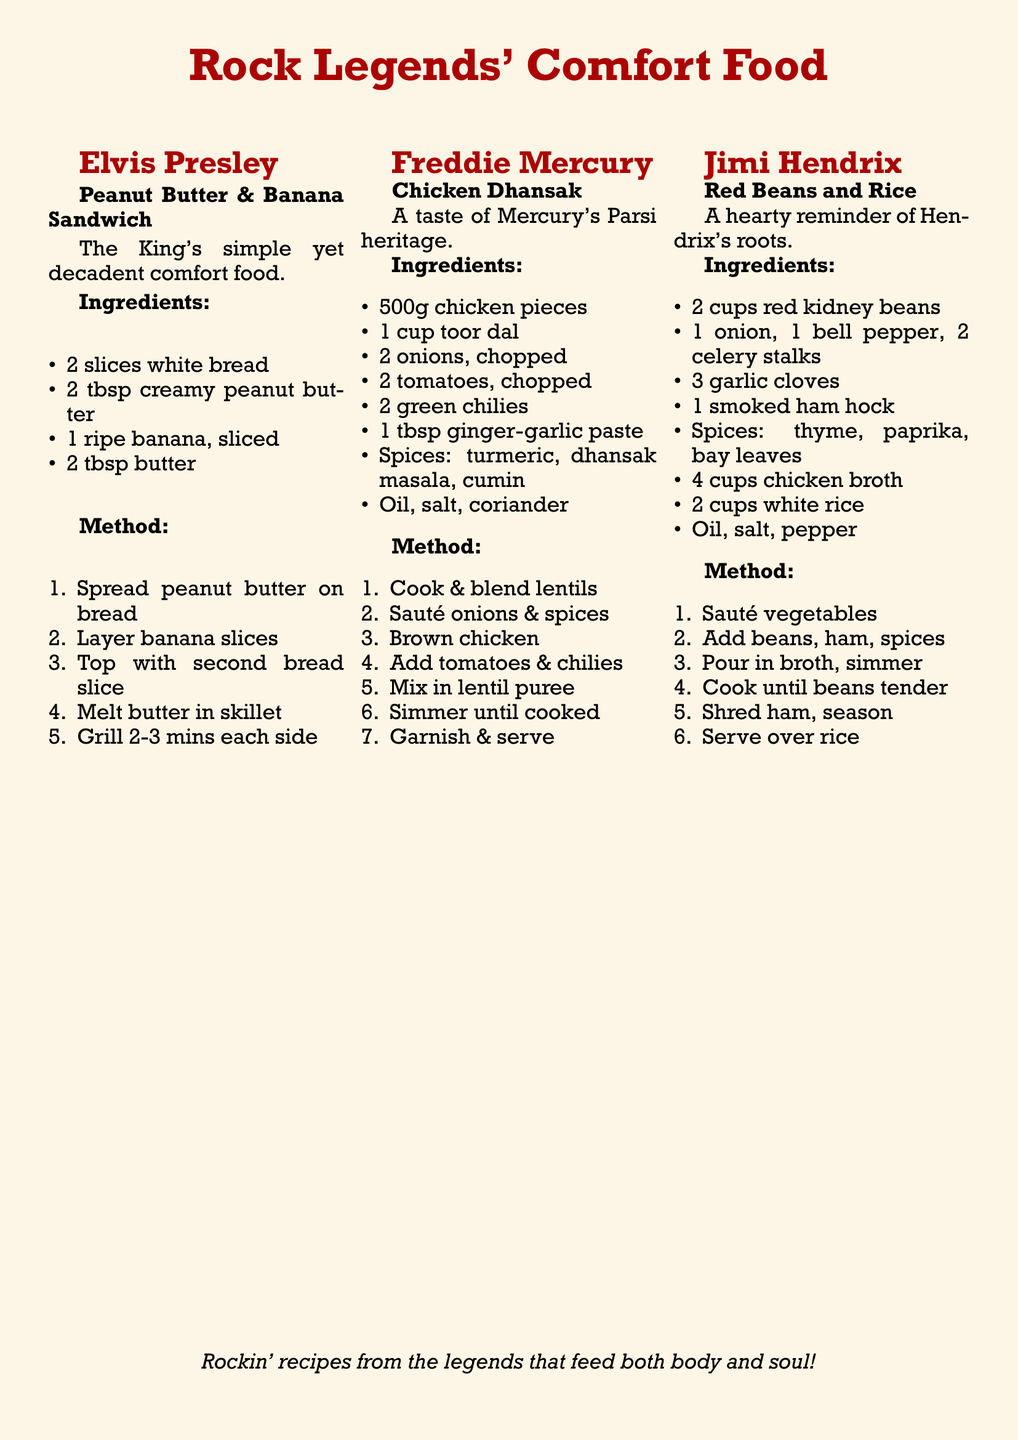What is the first recipe listed? The first recipe presented is for Elvis Presley's Peanut Butter & Banana Sandwich, which is mentioned at the beginning of the document.
Answer: Peanut Butter & Banana Sandwich Who is associated with Chicken Dhansak? The recipe for Chicken Dhansak is attributed to Freddie Mercury.
Answer: Freddie Mercury How many cups of red kidney beans are required for Jimi Hendrix's recipe? The recipe specifies 2 cups of red kidney beans as an ingredient.
Answer: 2 cups What spice is used in Chicken Dhansak? The recipe for Chicken Dhansak includes turmeric as one of the spices.
Answer: turmeric What is the cooking method for the Peanut Butter & Banana Sandwich? The method involves grilling the assembled sandwich in a skillet for 2-3 minutes on each side.
Answer: Grill How many ingredients are listed for the Chicken Dhansak? There are 8 ingredients listed for the Chicken Dhansak recipe in the document.
Answer: 8 What is a key ingredient in Jimi Hendrix's dish that provides flavor? The dish Red Beans and Rice includes a smoked ham hock, which adds flavor.
Answer: smoked ham hock What vegetable is included in the Red Beans and Rice recipe? The recipe includes onions as one of the vegetables.
Answer: onion 